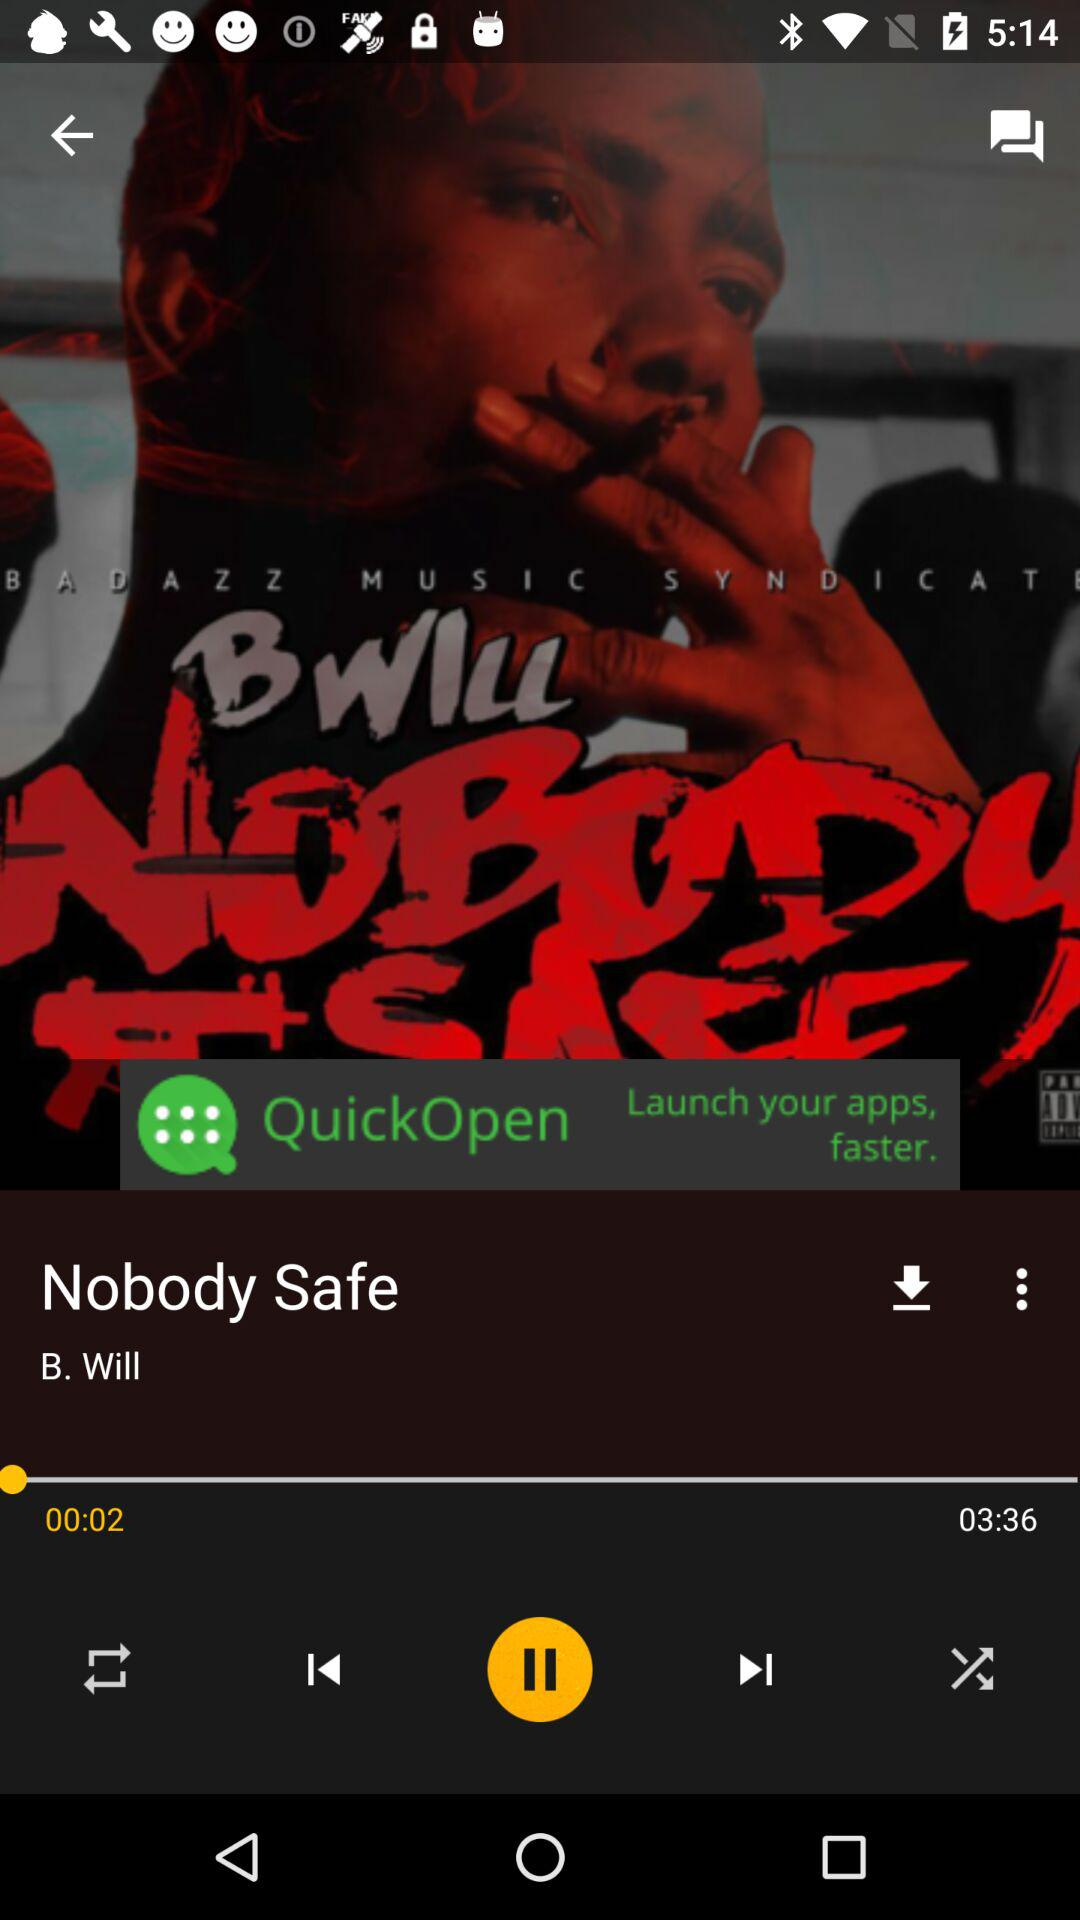How long has the video been playing? The video is 00:02 seconds long. 